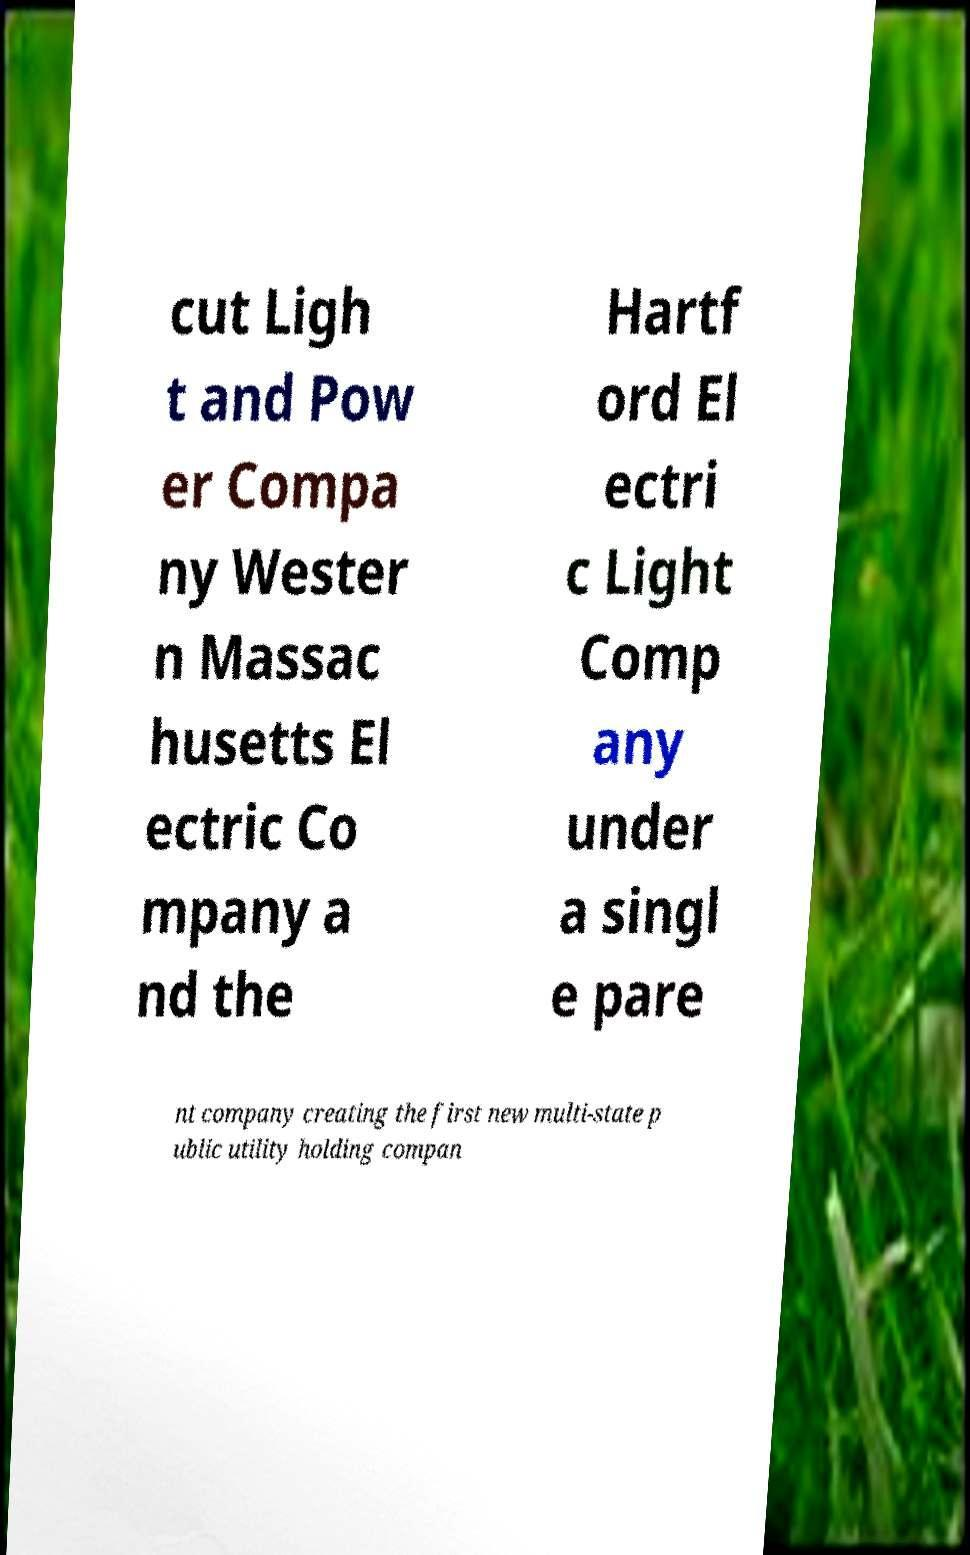I need the written content from this picture converted into text. Can you do that? cut Ligh t and Pow er Compa ny Wester n Massac husetts El ectric Co mpany a nd the Hartf ord El ectri c Light Comp any under a singl e pare nt company creating the first new multi-state p ublic utility holding compan 